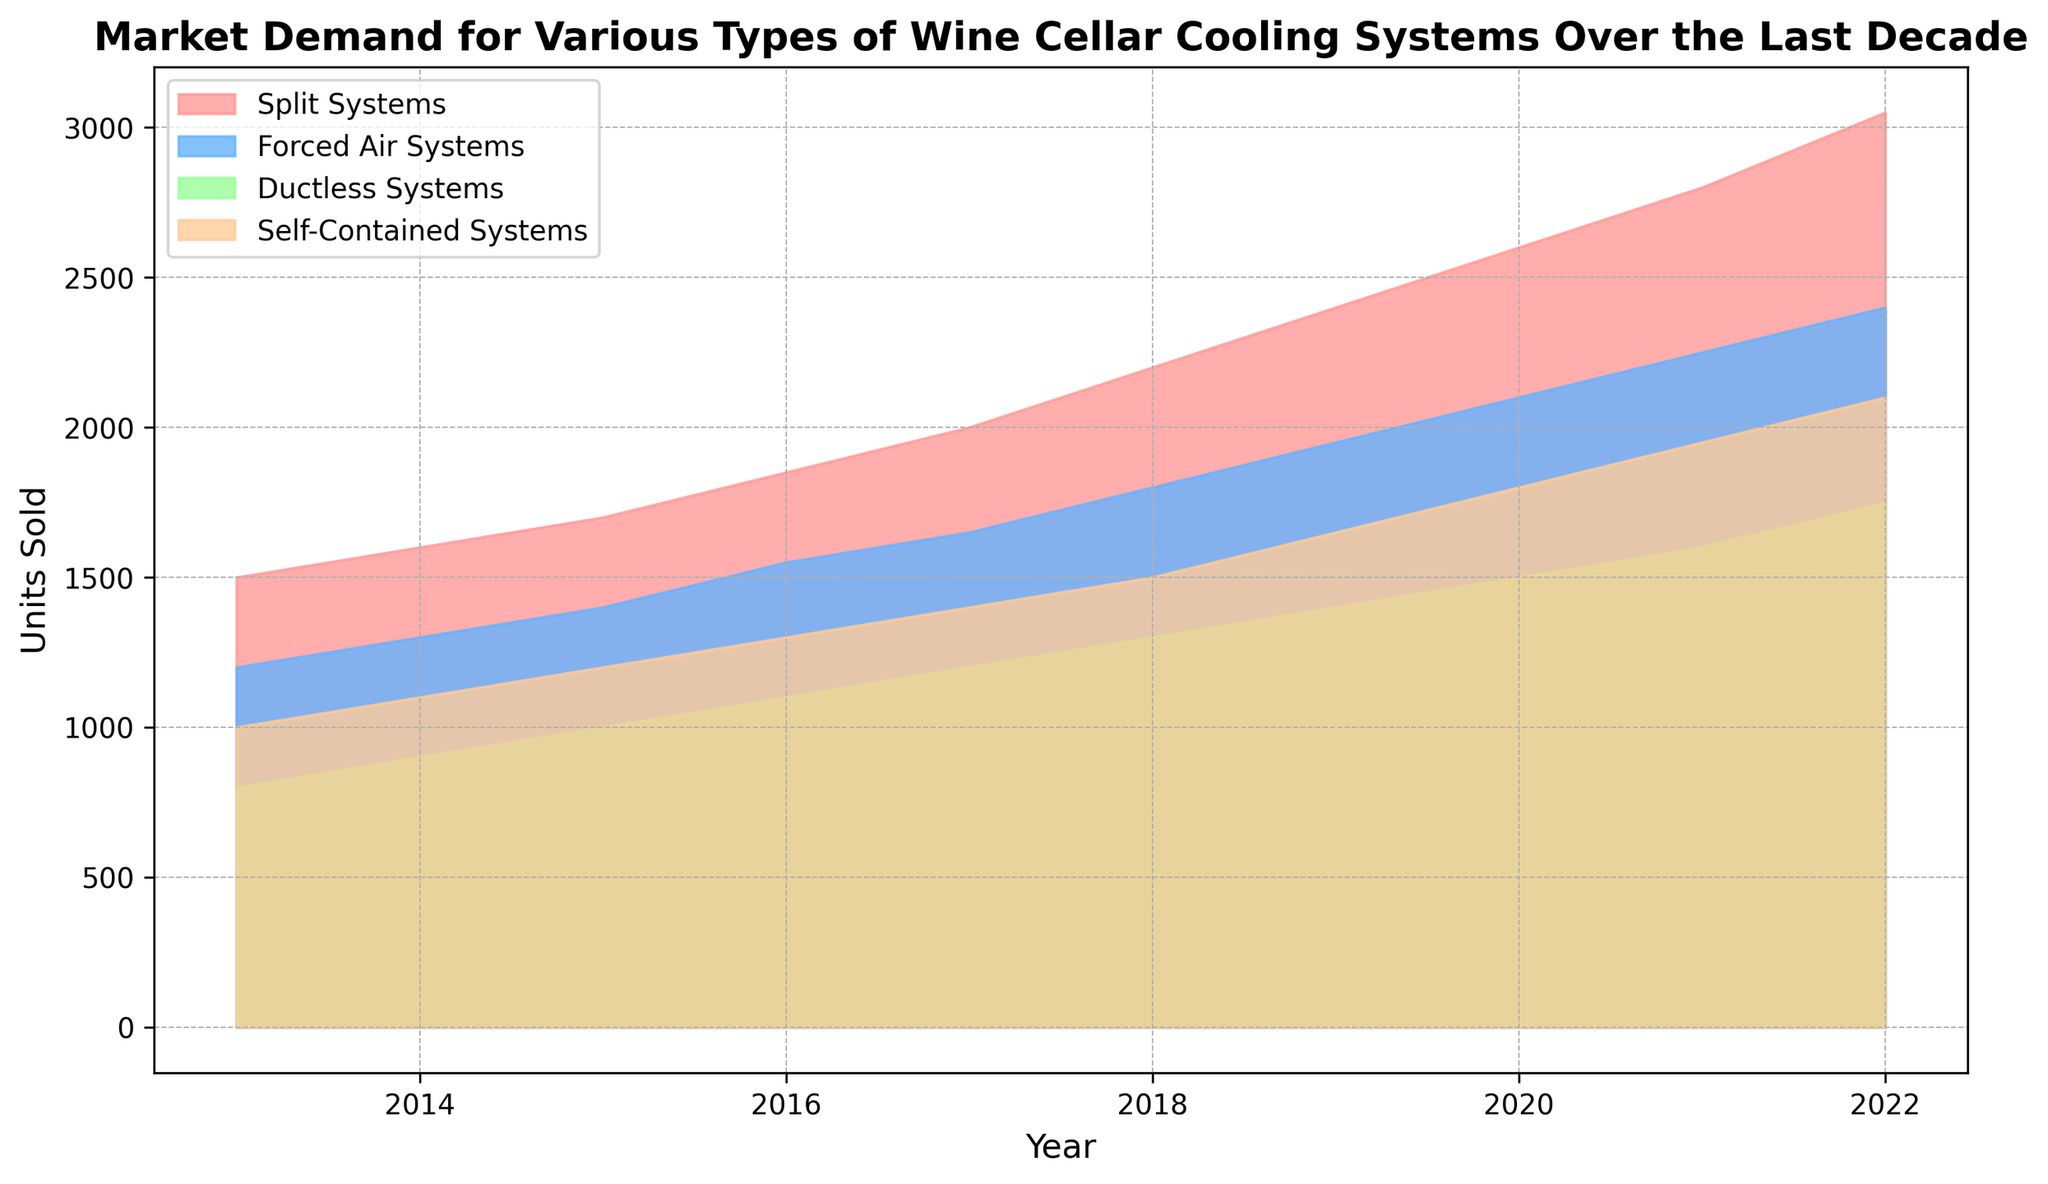Which type of wine cellar cooling system had the highest market demand in 2022? Look at the furthest right end of the chart for the year 2022 and identify which colored area has the highest peak. The red area representing Split Systems reaches the highest value.
Answer: Split Systems How did the market demand for Forced Air Systems change from 2015 to 2018? Inspect the blue area from 2015 to 2018. The height increases from 1400 units in 2015 to 1800 units in 2018, indicating a rise in market demand.
Answer: Increased Which cooling system saw the most consistent increase in demand over the decade? Evaluate the overall shape and slope of the areas. The red area (Split Systems) shows a consistent and steady upward trend with no dips or sharp increases.
Answer: Split Systems What is the total combined demand of all cooling systems in 2017? Add the values of all cooling systems for 2017: Split Systems (2000) + Forced Air Systems (1650) + Ductless Systems (1200) + Self-Contained Systems (1400). The sum is 6250 units.
Answer: 6250 units Which type of cooling system experienced the least growth from 2013 to 2022? Compare the starting and ending values of each colored area from 2013 to 2022. The orange area representing Self-Contained Systems shows the smallest increase from 1000 units in 2013 to 2100 units in 2022.
Answer: Self-Contained Systems Between 2019 and 2021, which cooling system type had the largest increase in market demand? Look at the difference in height between the years 2019 and 2021 for all areas. The red area for Split Systems increased from 2400 units in 2019 to 2800 units in 2021, an increase of 400 units.
Answer: Split Systems Which year had the lowest market demand for Ductless Systems? Identify the smallest height within the green area (Ductless Systems) throughout the years. The lowest point is in 2013 with 800 units.
Answer: 2013 What is the difference in market demand between Forced Air Systems and Ductless Systems in 2020? Find the demand for Forced Air Systems (2100 units) and Ductless Systems (1500 units) in 2020 and calculate the difference: 2100 - 1500 = 600 units.
Answer: 600 units In which years did all cooling systems have increasing market demand compared to the previous year? Check the chart year by year and ensure that each colored area increases each year without any dips. The years 2013 through 2022 continuously show increments across all systems.
Answer: 2013-2022 